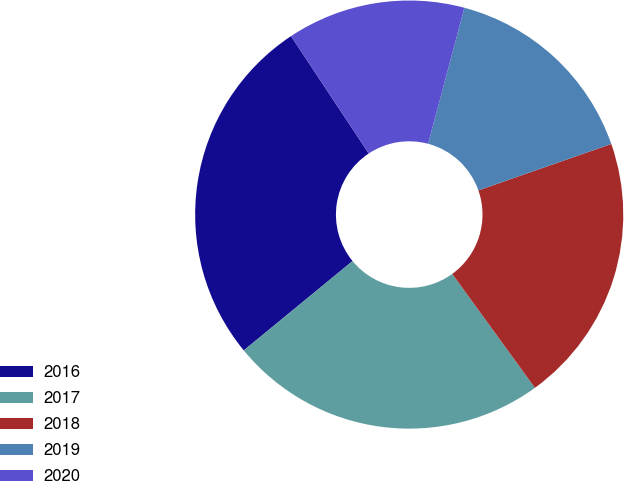<chart> <loc_0><loc_0><loc_500><loc_500><pie_chart><fcel>2016<fcel>2017<fcel>2018<fcel>2019<fcel>2020<nl><fcel>26.63%<fcel>24.05%<fcel>20.36%<fcel>15.5%<fcel>13.46%<nl></chart> 